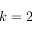<formula> <loc_0><loc_0><loc_500><loc_500>k = 2</formula> 